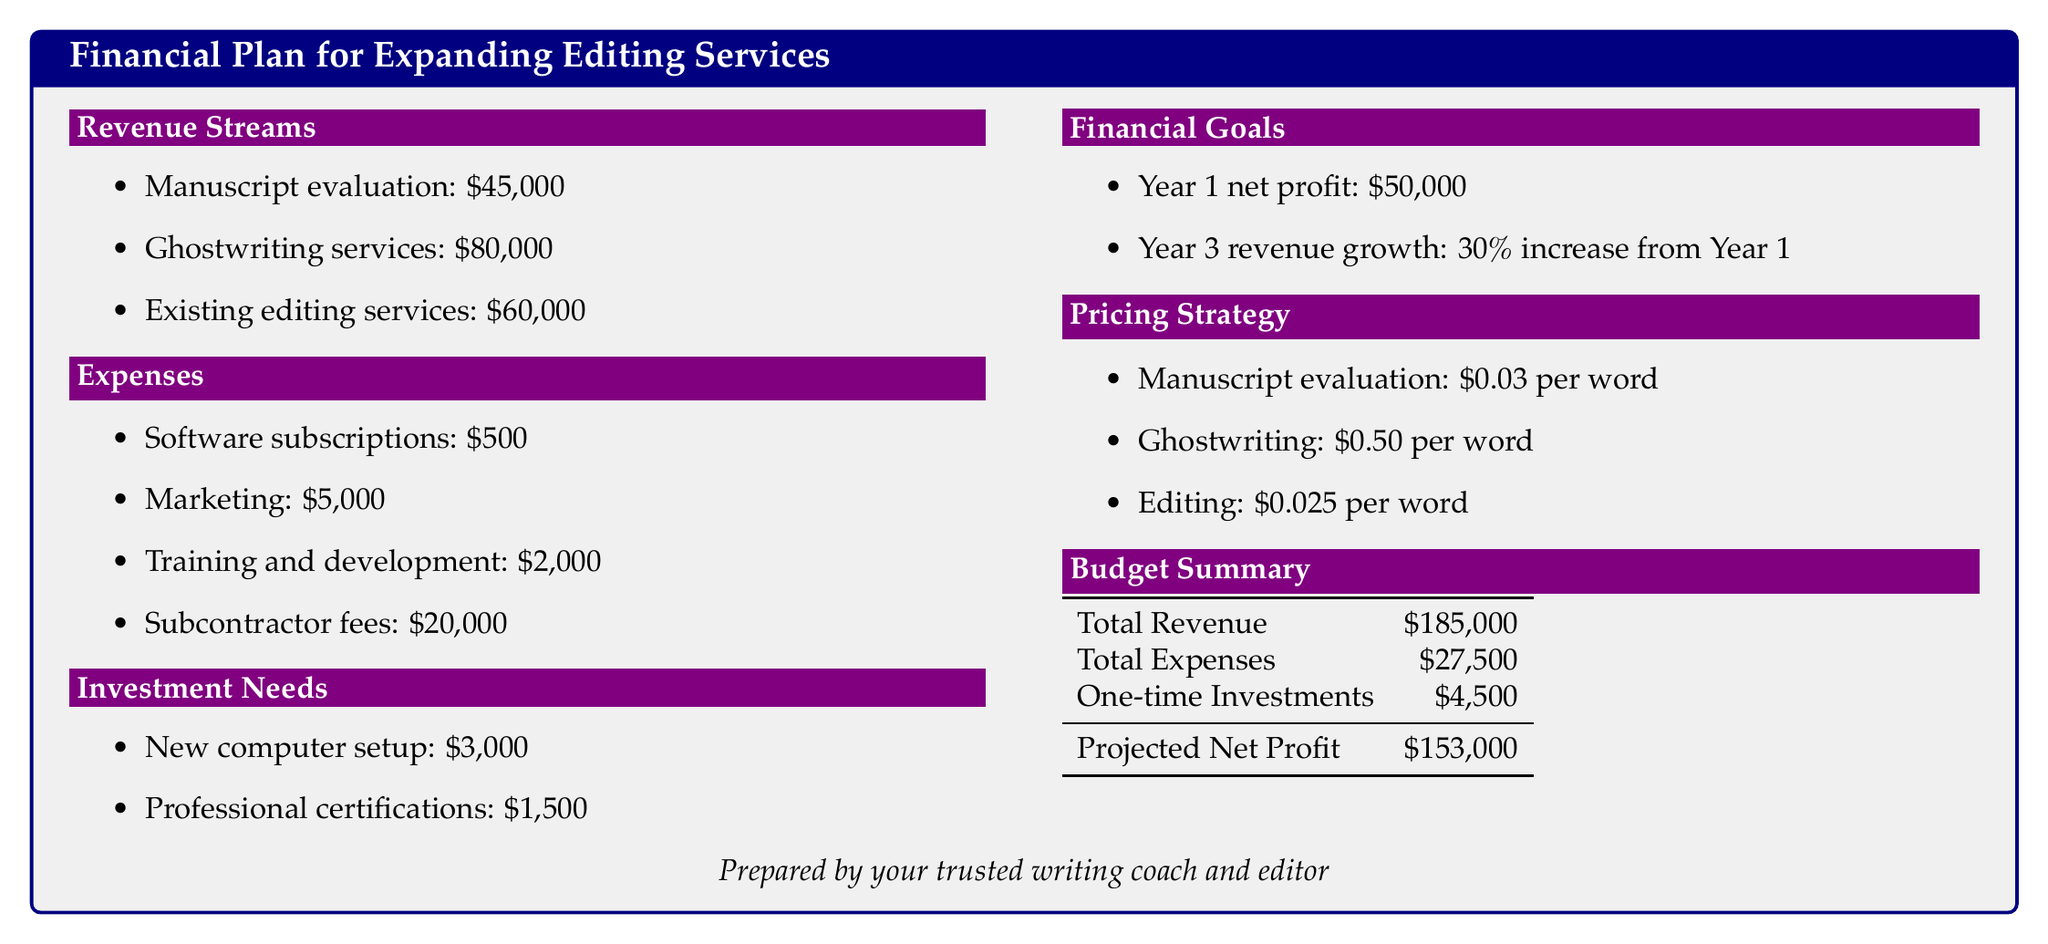What is the total revenue? The total revenue is the sum of all revenue sources listed: manuscript evaluation, ghostwriting services, and existing editing services.
Answer: $185,000 What is the budget for marketing? The document specifies the allocation for marketing under expenses, which amounts to $5,000.
Answer: $5,000 What are the investment needs listed? The investment needs include two specific items: a new computer setup and professional certifications.
Answer: New computer setup, professional certifications What is the revenue from ghostwriting services? The revenue generated from ghostwriting services is explicitly stated in the revenue streams section as $80,000.
Answer: $80,000 What is the projected net profit? The projected net profit is calculated after removing total expenses and one-time investments from total revenue, as shown in the budget summary.
Answer: $153,000 What is the pricing for manuscript evaluation? The pricing strategy section details the cost per word for manuscript evaluation.
Answer: $0.03 per word What is the total expenses amount? The total expenses listed add up to $27,500, as summarized in the budget summary table.
Answer: $27,500 What is the year 3 revenue growth target? The financial goals section mentions a specific target for revenue growth in year three relative to year one.
Answer: 30% increase from Year 1 What are the software subscriptions costs? The expenses section shows the cost allocated for software subscriptions, which is $500.
Answer: $500 What is the net profit for year 1? The net profit for year 1 is specified directly in the financial goals section.
Answer: $50,000 